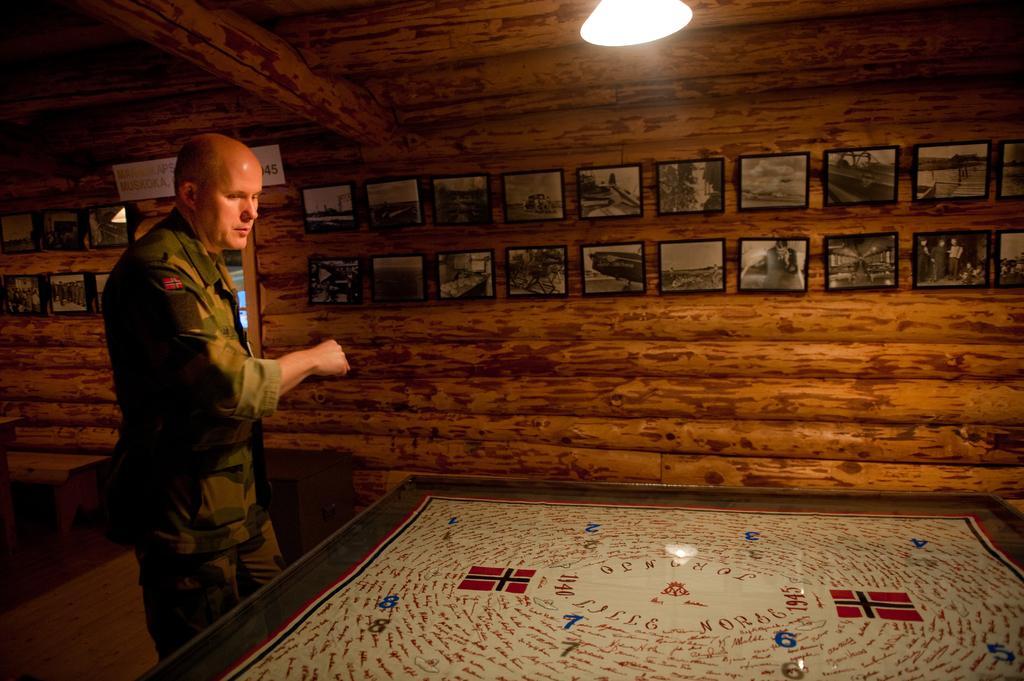Could you give a brief overview of what you see in this image? In this image I can see a the person standing in front of the table. At the back side there are frames on the wooden wall. On the top there is light. 